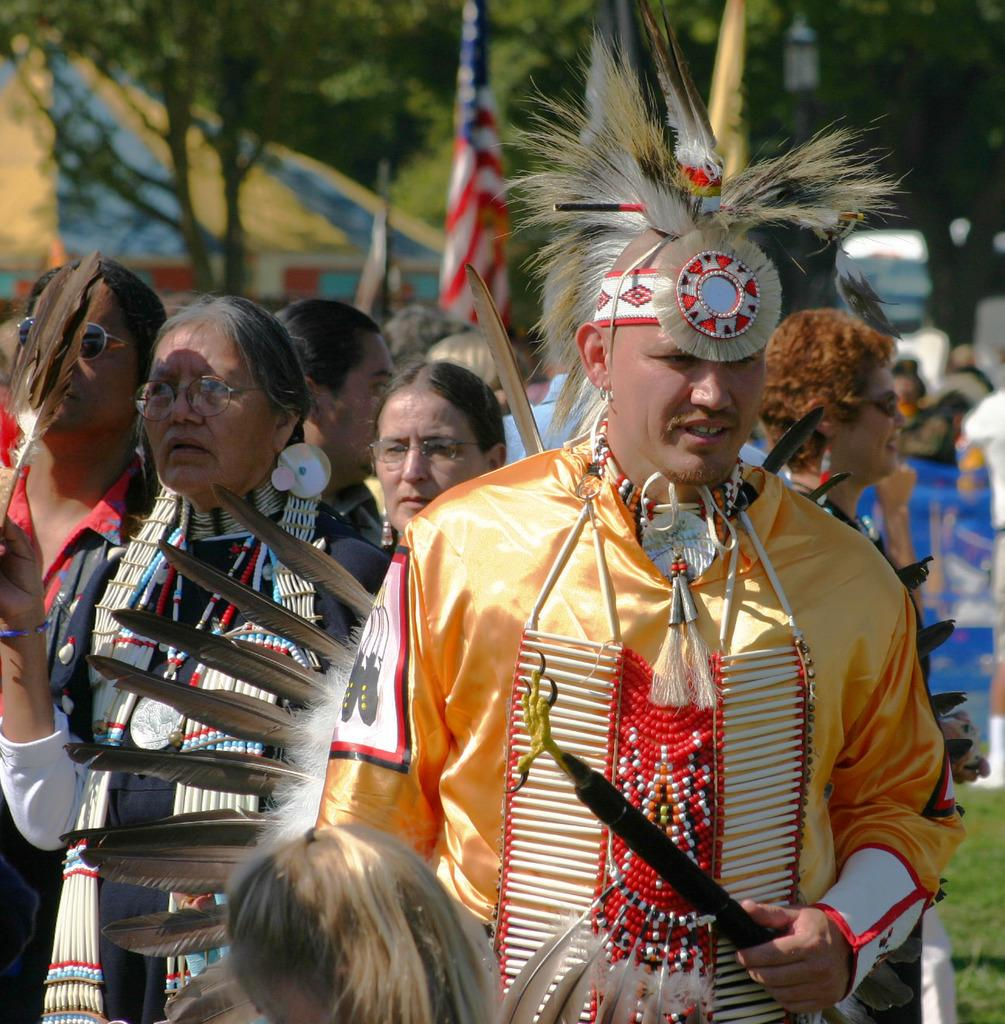How many persons are in the image? There are persons in the image, but the exact number is not specified. What is the person wearing that stands out in the image? One person is wearing a fancy dress. What can be seen in the background of the image? There are flags, a pole, a light, trees, and a house in the background of the image. What type of veil is the person wearing in the image? There is no mention of a veil in the image; the person is wearing a fancy dress. How many people are in the crowd in the image? There is no mention of a crowd in the image; the number of persons is not specified. 